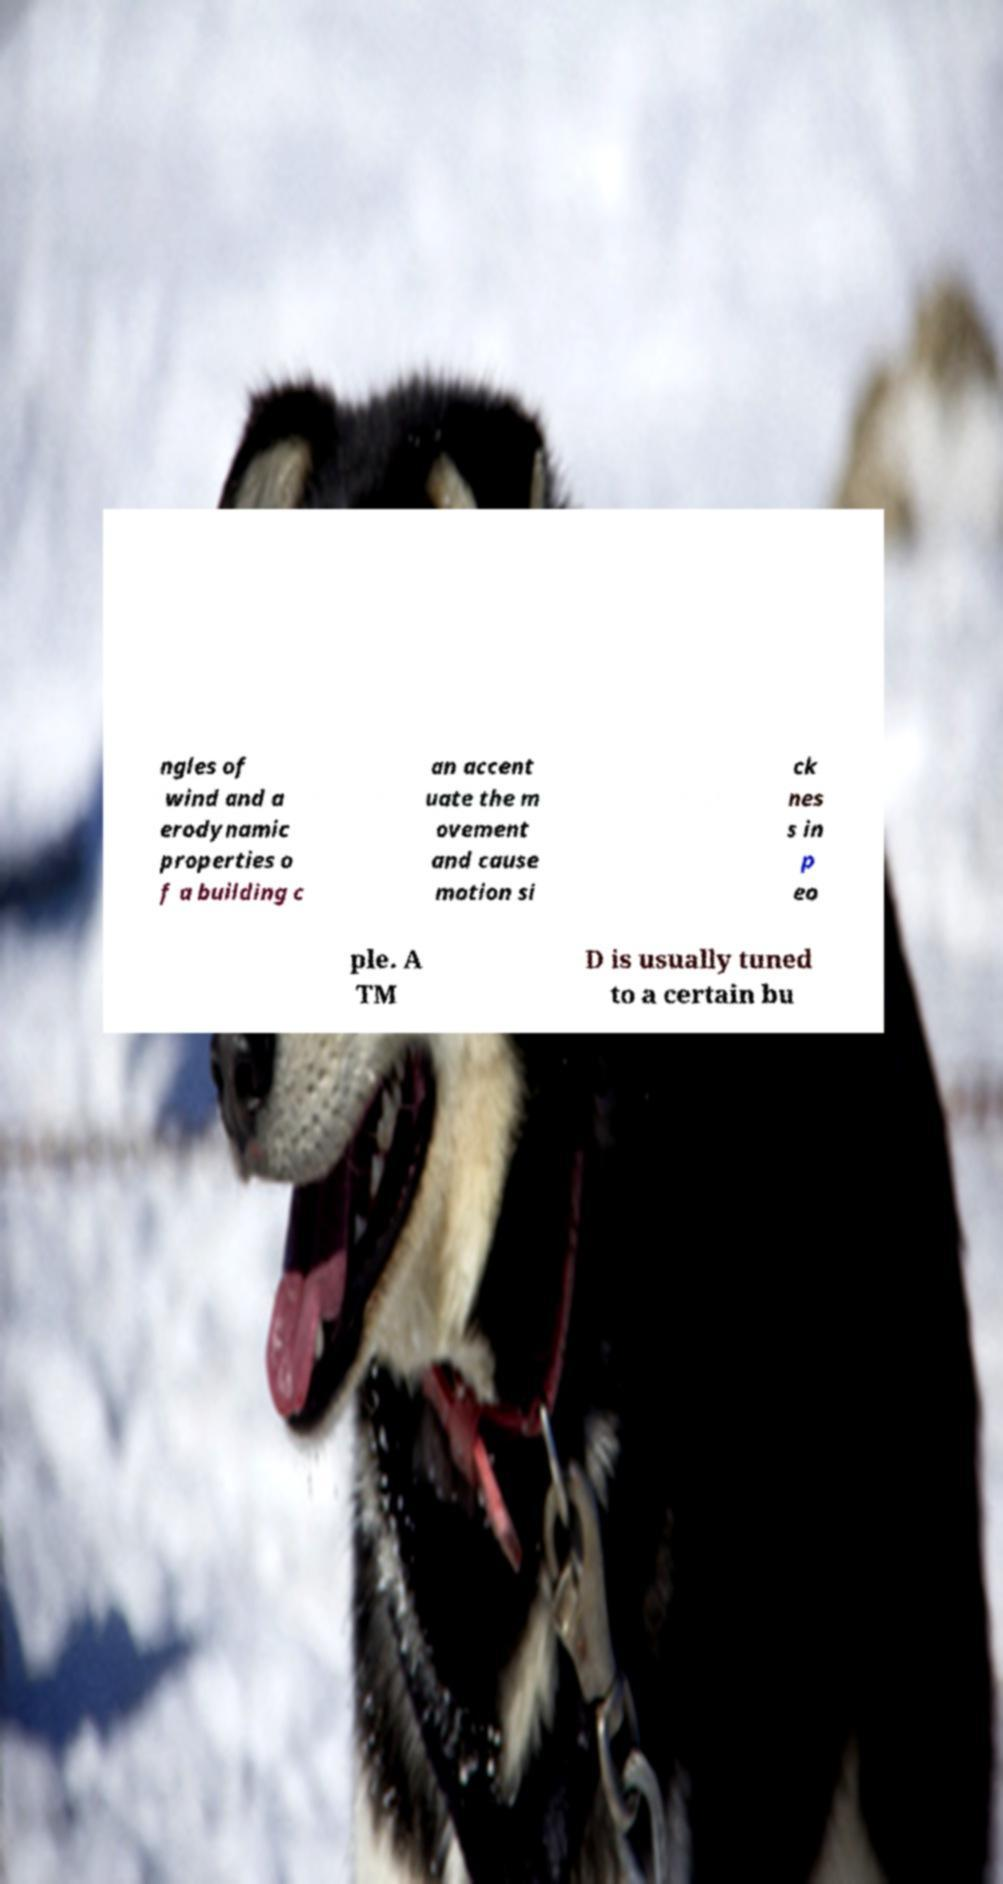What messages or text are displayed in this image? I need them in a readable, typed format. ngles of wind and a erodynamic properties o f a building c an accent uate the m ovement and cause motion si ck nes s in p eo ple. A TM D is usually tuned to a certain bu 